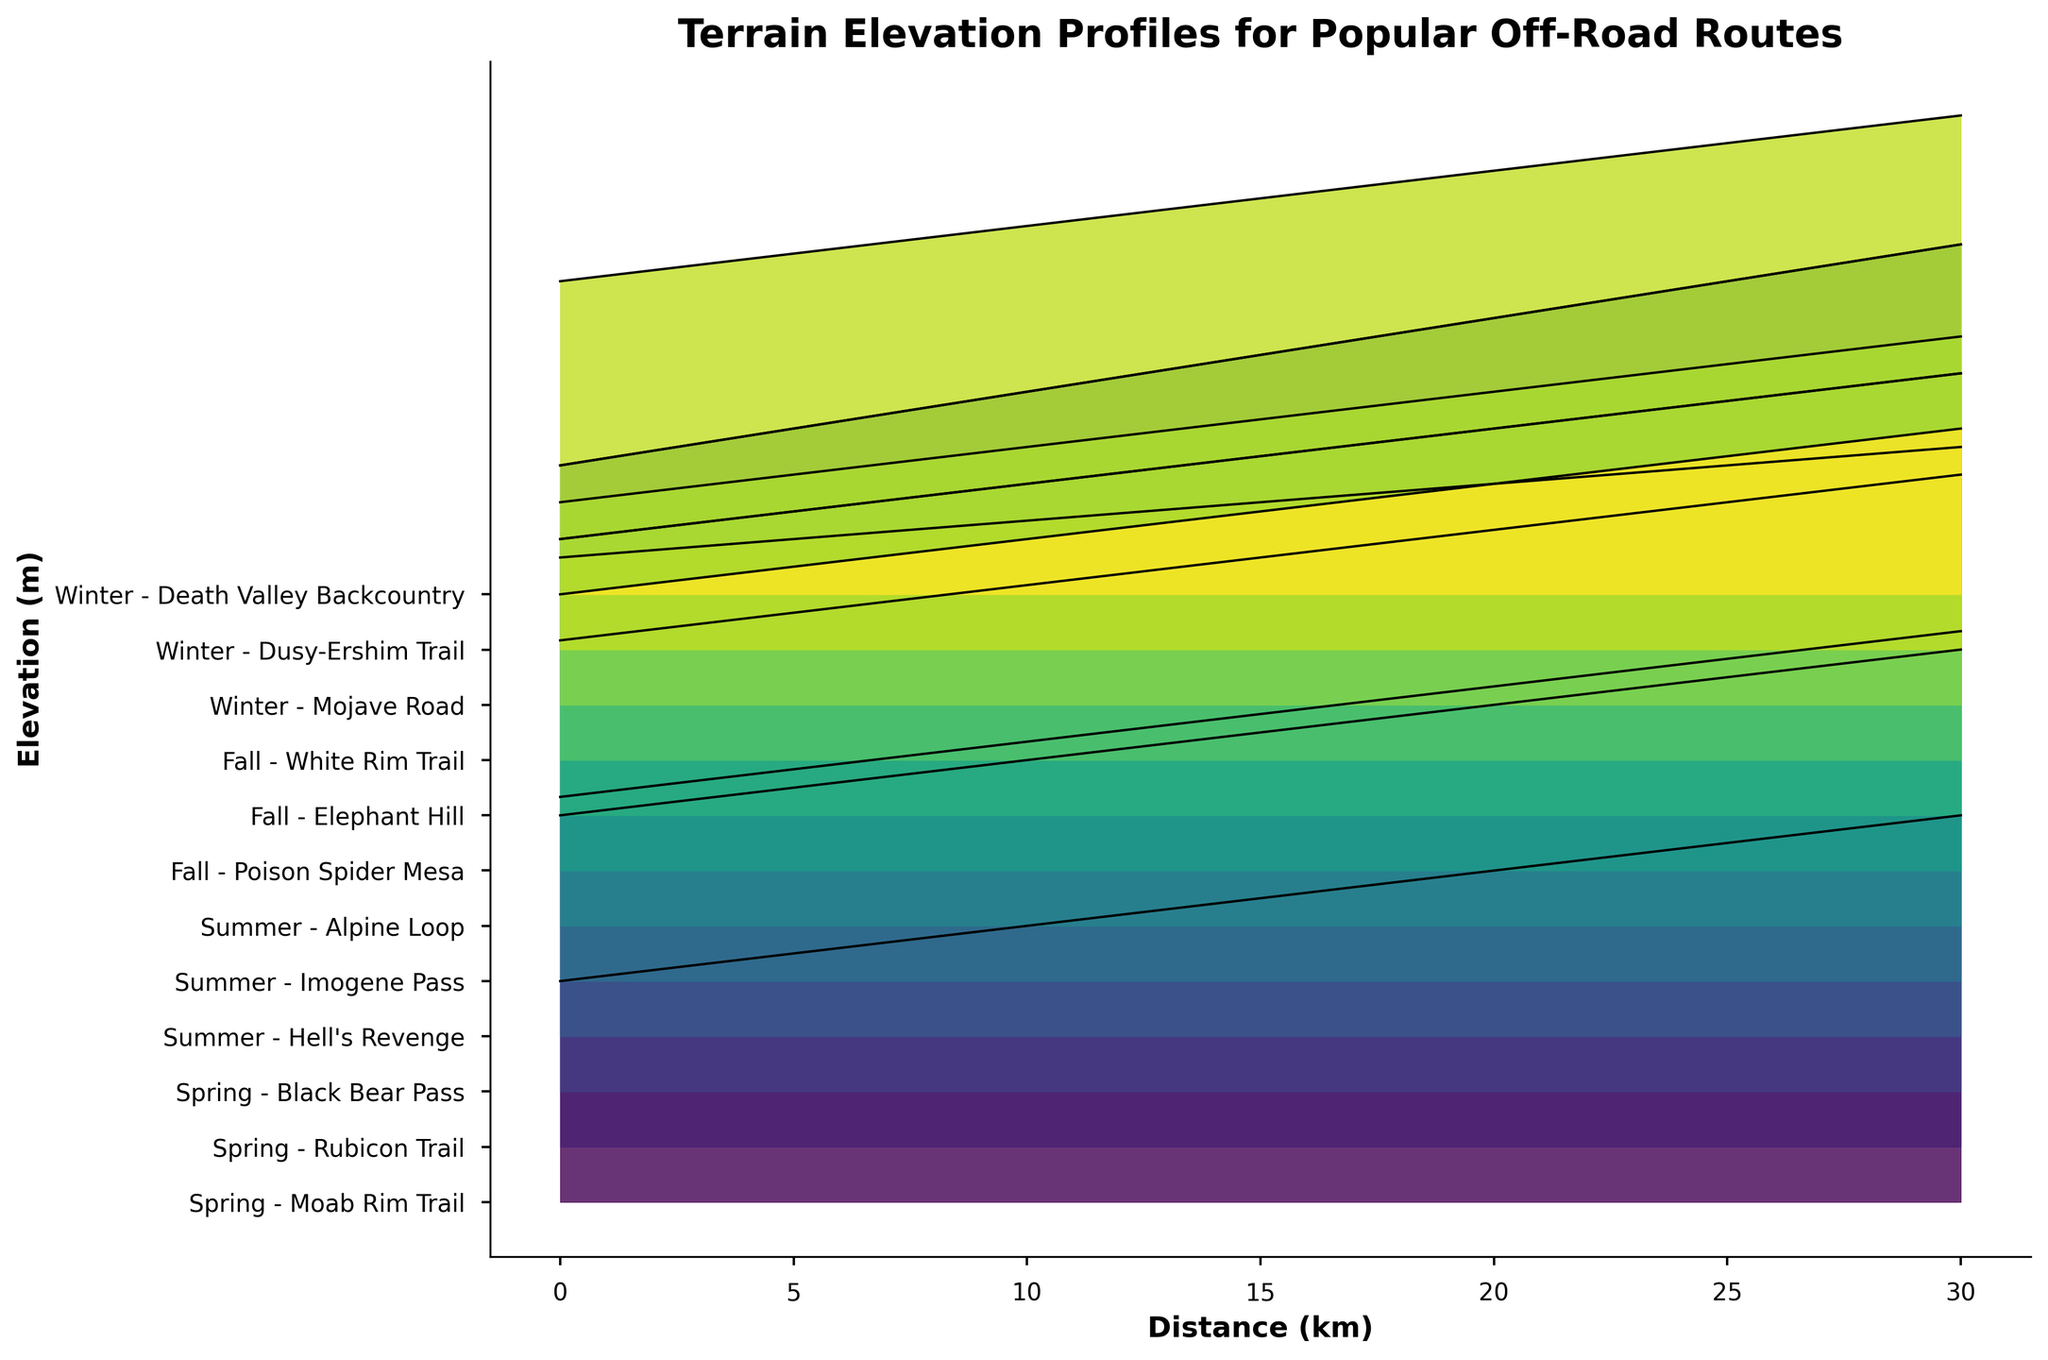What is the title of the plot? The title of the plot is usually located at the top of the figure and is written in bold text. It helps in understanding the main subject of the figure.
Answer: Terrain Elevation Profiles for Popular Off-Road Routes How many routes are displayed for the Summer season? By looking at the y-axis labels, we can count the number of routes associated with the "Summer" season.
Answer: 3 Which route has the highest starting elevation? The starting elevation is found at the 0 km mark on the x-axis. By comparing the starting points of all routes, we can identify the highest one. Black Bear Pass starts at 3000 meters, the highest.
Answer: Black Bear Pass What is the average elevation at 10 km for all routes in the Fall season? First, identify the elevations of Fall routes at 10 km (1550, 1800, 1700). Sum these values (1550 + 1800 + 1700 = 5050) and then divide by the number of routes (3).
Answer: 1683.33 meters Which Summer route has the greatest change in elevation from 0 km to 30 km? Calculate the change by subtracting the 0 km elevation from the 30 km elevation for each Summer route and compare the values. Imogene Pass has the greatest change: 4000 - 2800 = 1200 meters.
Answer: Imogene Pass Is there any route that shows a strictly increasing elevation profile? Traverse each route from 0 km to 30 km to check if every subsequent kilometer point has a higher elevation than the previous. Black Bear Pass shows strictly increasing values.
Answer: Black Bear Pass How does the elevation change in the first 5 km for Mojave Road in Winter? By looking at the Mojave Road data points from 0 km (800 meters) to 5 km (900 meters), we notice the increase. The elevation rises by 100 meters.
Answer: Rises by 100 meters Comparing Alpine Loop and Imogene Pass, which one ends at a higher elevation? Compare the elevation at 30 km for both routes. Alpine Loop ends at 3700 meters while Imogene Pass ends at 4000 meters. Thus, Imogene Pass ends higher.
Answer: Imogene Pass What is the median starting elevation for all Spring routes? First, list the starting elevations for all Spring routes (1200, 1800, 3000), then sort the values (1200, 1800, 3000). The middle value is the median.
Answer: 1800 meters 